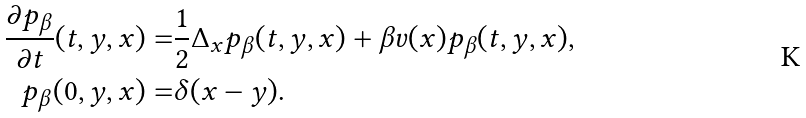<formula> <loc_0><loc_0><loc_500><loc_500>\frac { \partial p _ { \beta } } { \partial t } ( t , y , x ) = & \frac { 1 } { 2 } \Delta _ { x } p _ { \beta } ( t , y , x ) + \beta v ( x ) p _ { \beta } ( t , y , x ) , \\ p _ { \beta } ( 0 , y , x ) = & \delta ( x - y ) .</formula> 